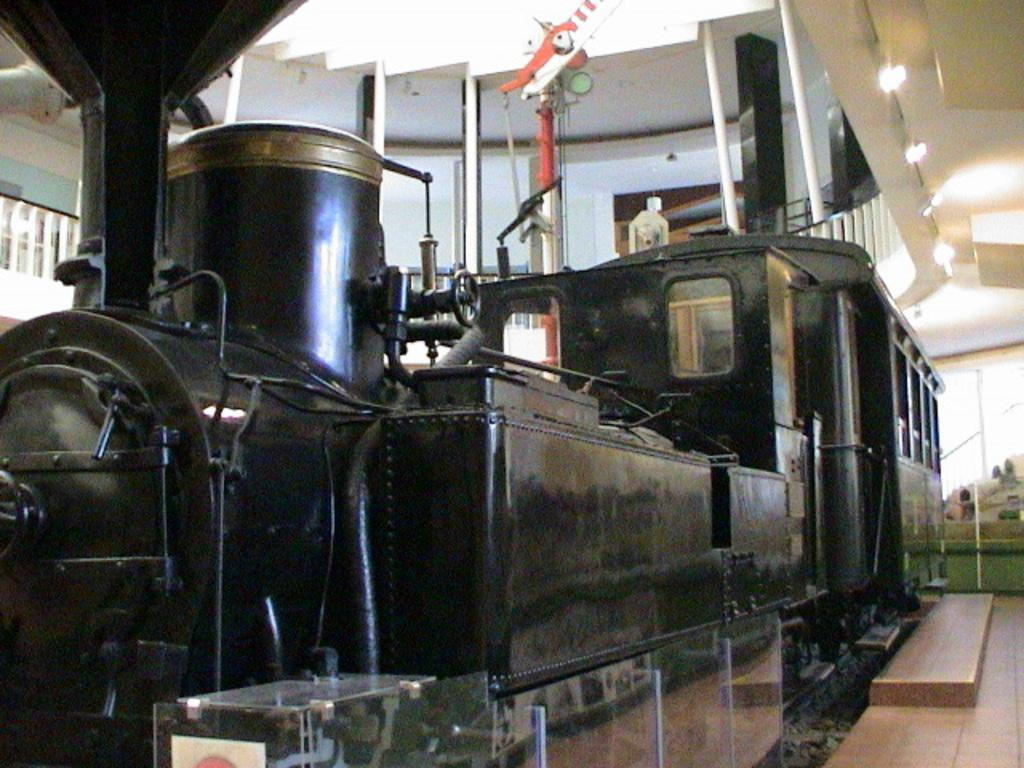What is the main subject of the image? The main subject of the image is a train engine. What can you tell me about the color of the train engine? The train engine is black in color. Can you see a hose attached to the train engine in the image? There is no hose visible in the image; it only features a black train engine. Is the train engine crying in the image? Trains do not have the ability to cry, and there is no indication of any emotional expression in the image. 